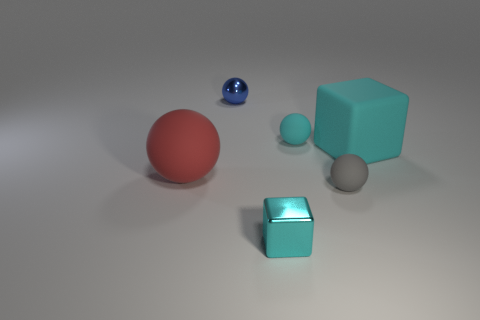How many other things are there of the same material as the big ball?
Your response must be concise. 3. Do the metallic thing in front of the matte cube and the small matte ball in front of the cyan sphere have the same color?
Offer a very short reply. No. The large object left of the small rubber sphere that is in front of the big cyan rubber cube is what shape?
Your answer should be very brief. Sphere. How many other objects are there of the same color as the big ball?
Your answer should be very brief. 0. Do the small cyan thing behind the small cyan metal cube and the object in front of the gray matte thing have the same material?
Give a very brief answer. No. What size is the metal object behind the large ball?
Provide a short and direct response. Small. What is the material of the other cyan object that is the same shape as the large cyan object?
Your response must be concise. Metal. The shiny object that is behind the small cyan matte ball has what shape?
Offer a terse response. Sphere. What number of tiny cyan rubber things are the same shape as the small blue metal object?
Your answer should be compact. 1. Is the number of small shiny blocks that are in front of the metallic ball the same as the number of big cyan things that are in front of the tiny cube?
Keep it short and to the point. No. 